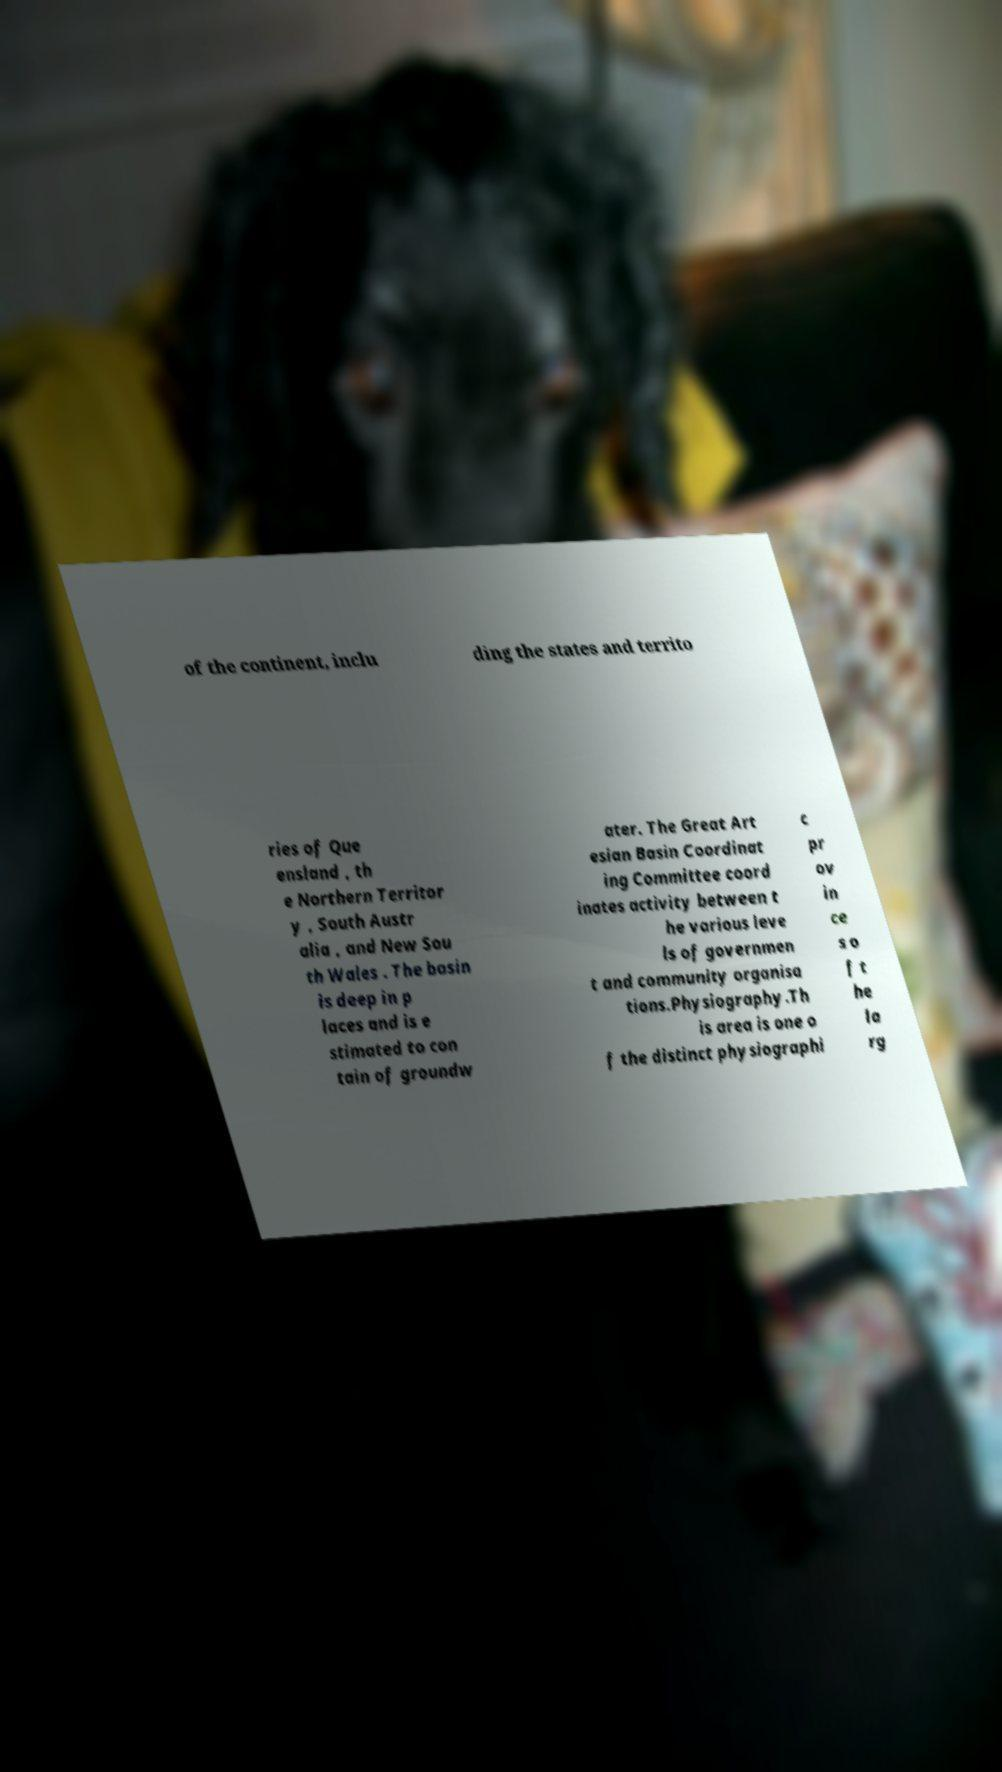Could you extract and type out the text from this image? of the continent, inclu ding the states and territo ries of Que ensland , th e Northern Territor y , South Austr alia , and New Sou th Wales . The basin is deep in p laces and is e stimated to con tain of groundw ater. The Great Art esian Basin Coordinat ing Committee coord inates activity between t he various leve ls of governmen t and community organisa tions.Physiography.Th is area is one o f the distinct physiographi c pr ov in ce s o f t he la rg 